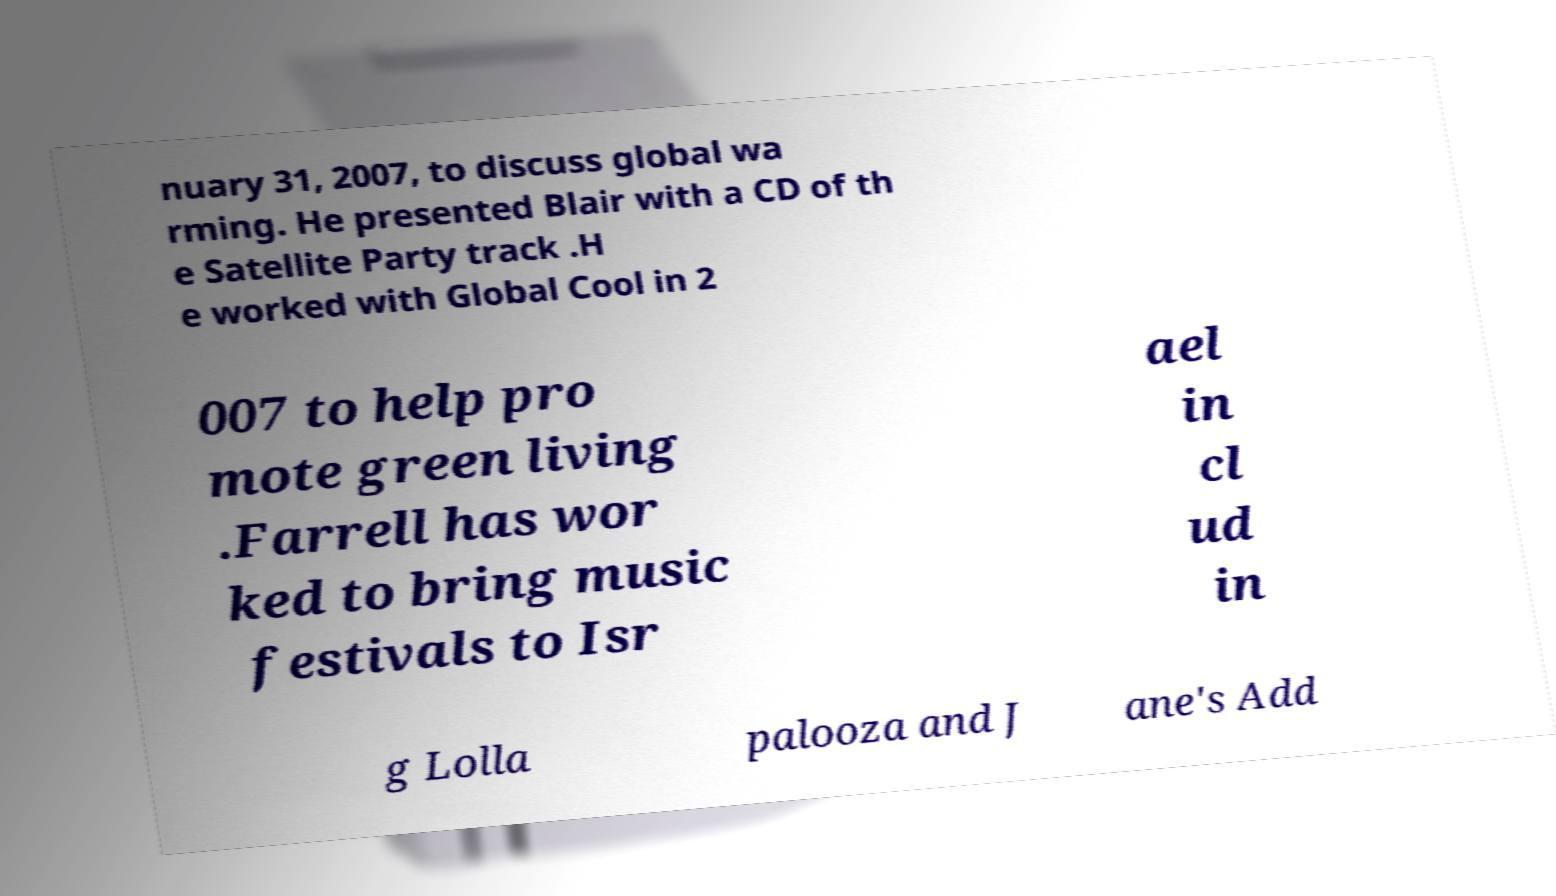What messages or text are displayed in this image? I need them in a readable, typed format. nuary 31, 2007, to discuss global wa rming. He presented Blair with a CD of th e Satellite Party track .H e worked with Global Cool in 2 007 to help pro mote green living .Farrell has wor ked to bring music festivals to Isr ael in cl ud in g Lolla palooza and J ane's Add 